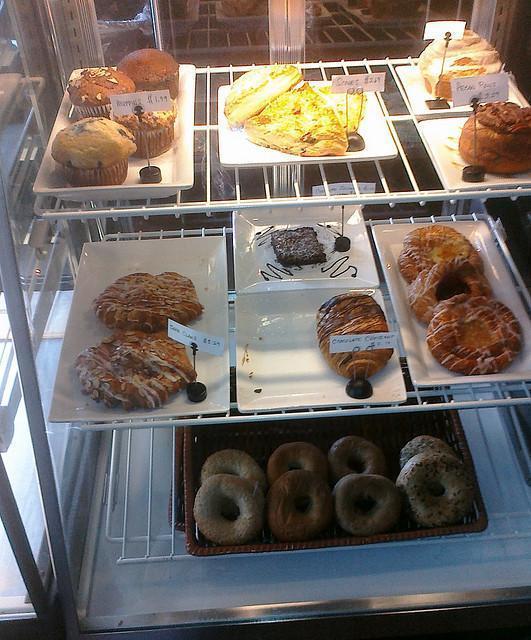How many donuts are there?
Give a very brief answer. 11. How many cakes are there?
Give a very brief answer. 6. 